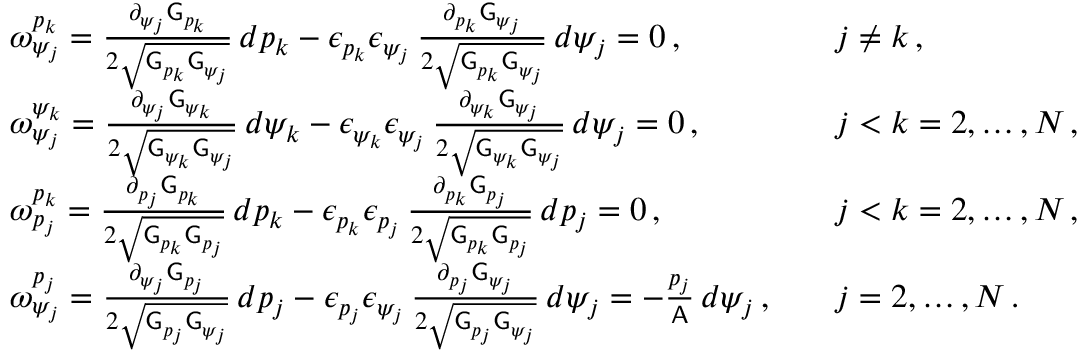<formula> <loc_0><loc_0><loc_500><loc_500>\begin{array} { r l r l } & { \omega ^ { p _ { k } } _ { \psi _ { j } } = \frac { \partial _ { \psi _ { j } } G _ { p _ { k } } } { 2 \sqrt { G _ { p _ { k } } G _ { \psi _ { j } } } } \, d p _ { k } - \epsilon _ { p _ { k } } \epsilon _ { \psi _ { j } } \, \frac { \partial _ { p _ { k } } G _ { \psi _ { j } } } { 2 \sqrt { G _ { p _ { k } } G _ { \psi _ { j } } } } \, d \psi _ { j } = 0 \, , } & & { j \neq k \, , } \\ & { \omega ^ { \psi _ { k } } _ { \psi _ { j } } = \frac { \partial _ { \psi _ { j } } G _ { \psi _ { k } } } { 2 \sqrt { G _ { \psi _ { k } } G _ { \psi _ { j } } } } \, d \psi _ { k } - \epsilon _ { \psi _ { k } } \epsilon _ { \psi _ { j } } \, \frac { \partial _ { \psi _ { k } } G _ { \psi _ { j } } } { 2 \sqrt { G _ { \psi _ { k } } G _ { \psi _ { j } } } } \, d \psi _ { j } = 0 \, , } & & { j < k = 2 , \hdots , N \, , } \\ & { \omega ^ { p _ { k } } _ { p _ { j } } = \frac { \partial _ { p _ { j } } G _ { p _ { k } } } { 2 \sqrt { G _ { p _ { k } } G _ { p _ { j } } } } \, d p _ { k } - \epsilon _ { p _ { k } } \epsilon _ { p _ { j } } \, \frac { \partial _ { p _ { k } } G _ { p _ { j } } } { 2 \sqrt { G _ { p _ { k } } G _ { p _ { j } } } } \, d p _ { j } = 0 \, , } & & { j < k = 2 , \hdots , N \, , } \\ & { \omega ^ { p _ { j } } _ { \psi _ { j } } = \frac { \partial _ { \psi _ { j } } G _ { p _ { j } } } { 2 \sqrt { G _ { p _ { j } } G _ { \psi _ { j } } } } \, d p _ { j } - \epsilon _ { p _ { j } } \epsilon _ { \psi _ { j } } \, \frac { \partial _ { p _ { j } } G _ { \psi _ { j } } } { 2 \sqrt { G _ { p _ { j } } G _ { \psi _ { j } } } } \, d \psi _ { j } = - \frac { p _ { j } } { A } \, d \psi _ { j } \, , } & & { j = 2 , \hdots , N \, . } \end{array}</formula> 